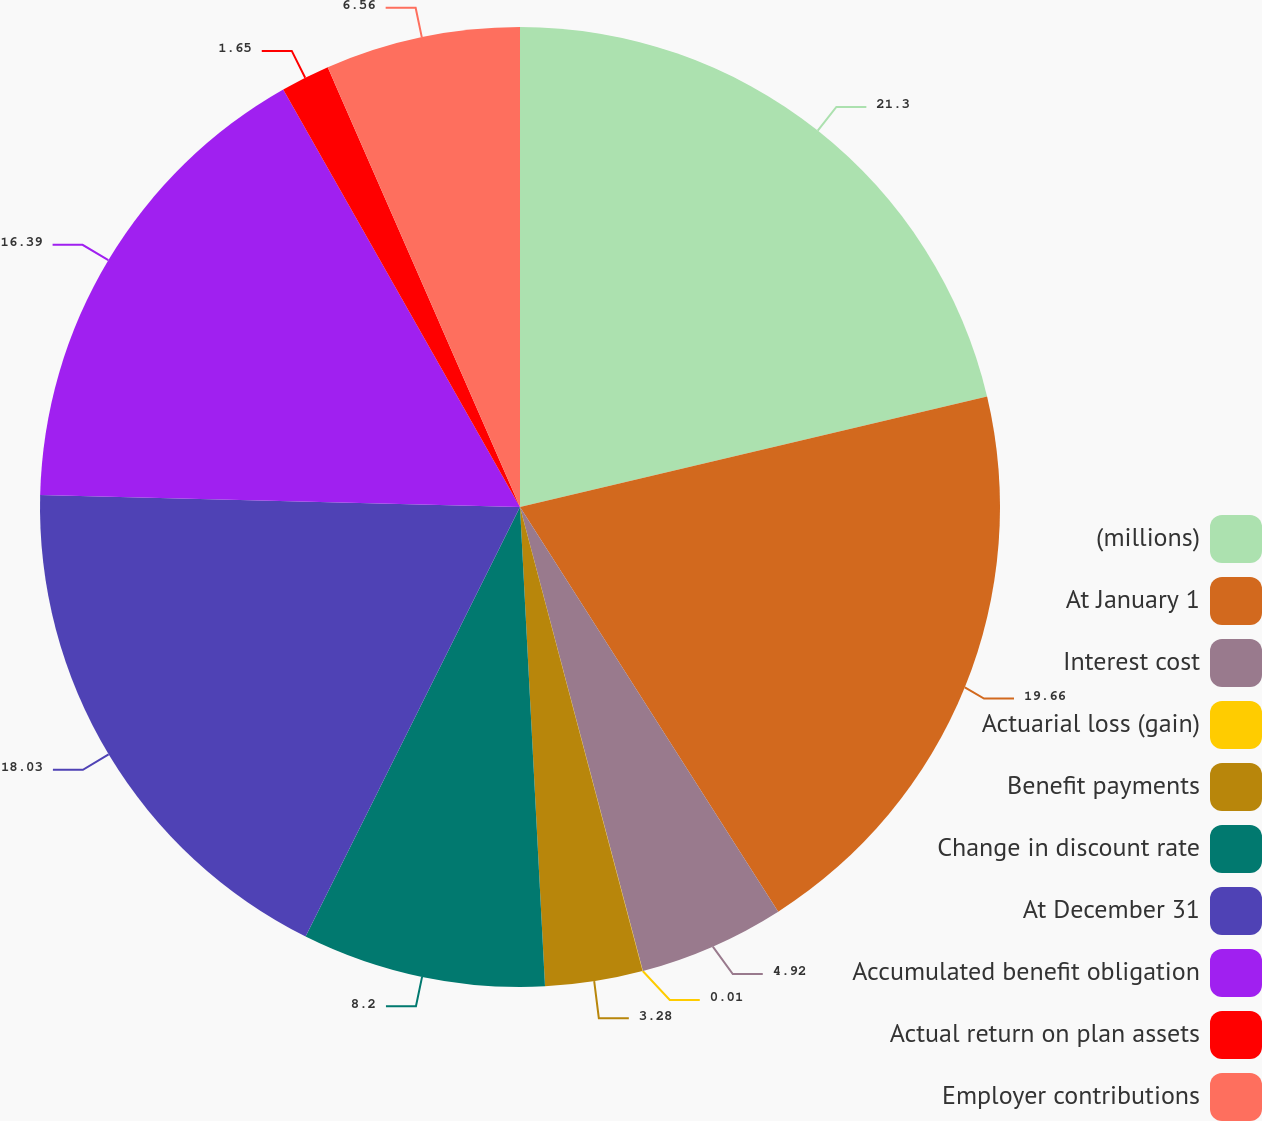<chart> <loc_0><loc_0><loc_500><loc_500><pie_chart><fcel>(millions)<fcel>At January 1<fcel>Interest cost<fcel>Actuarial loss (gain)<fcel>Benefit payments<fcel>Change in discount rate<fcel>At December 31<fcel>Accumulated benefit obligation<fcel>Actual return on plan assets<fcel>Employer contributions<nl><fcel>21.3%<fcel>19.66%<fcel>4.92%<fcel>0.01%<fcel>3.28%<fcel>8.2%<fcel>18.03%<fcel>16.39%<fcel>1.65%<fcel>6.56%<nl></chart> 